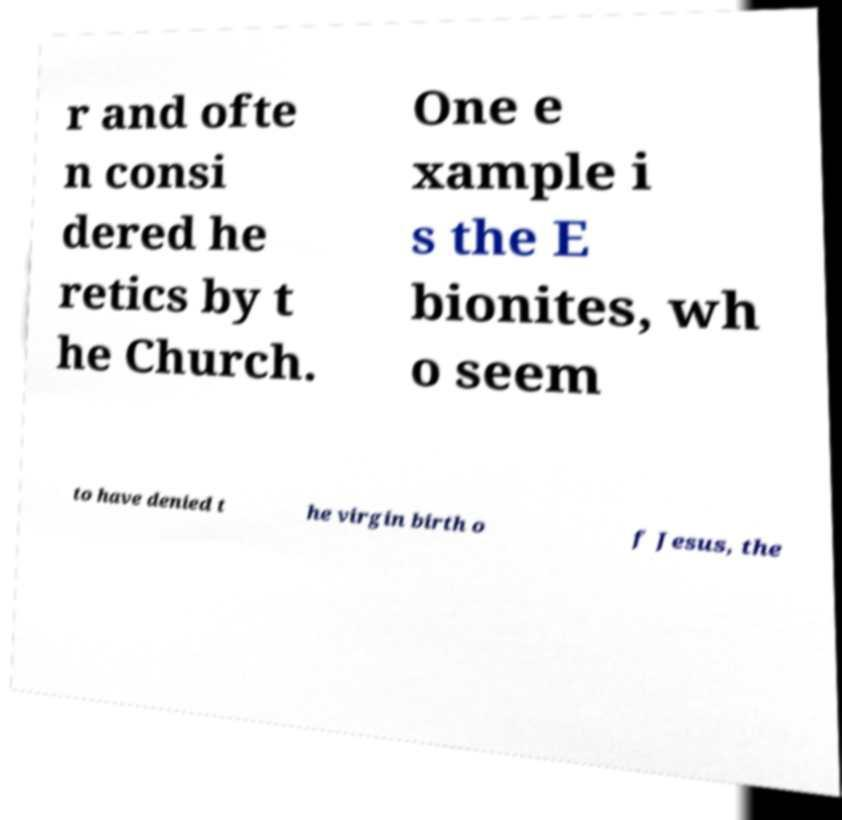Please identify and transcribe the text found in this image. r and ofte n consi dered he retics by t he Church. One e xample i s the E bionites, wh o seem to have denied t he virgin birth o f Jesus, the 